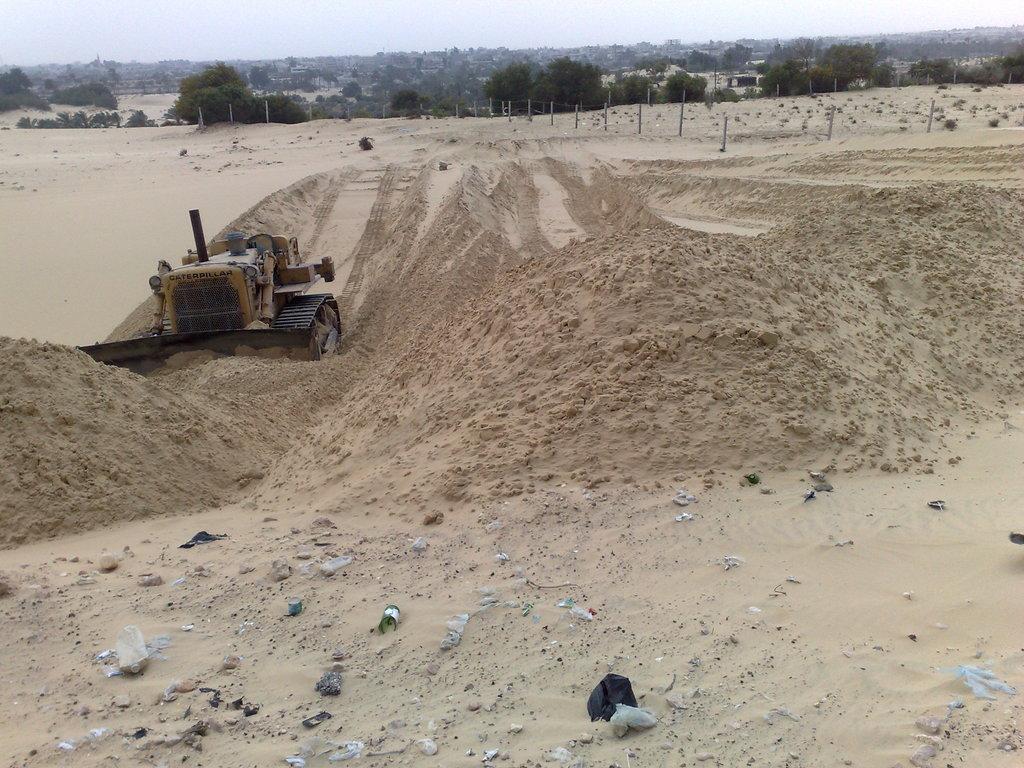In one or two sentences, can you explain what this image depicts? In this image there is a tractor present on the sand. In the background we can see many trees. Fence is also visible. Sky is also present in this image. 